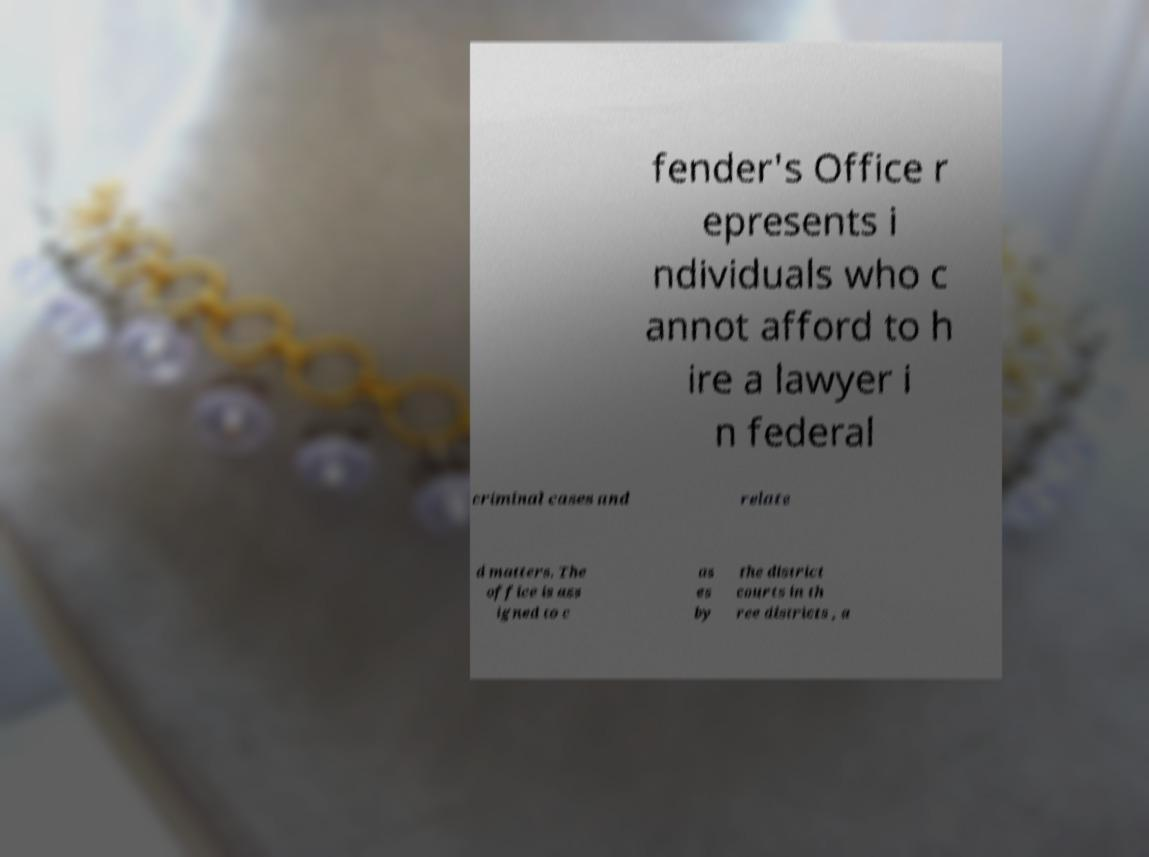Please read and relay the text visible in this image. What does it say? fender's Office r epresents i ndividuals who c annot afford to h ire a lawyer i n federal criminal cases and relate d matters. The office is ass igned to c as es by the district courts in th ree districts , a 